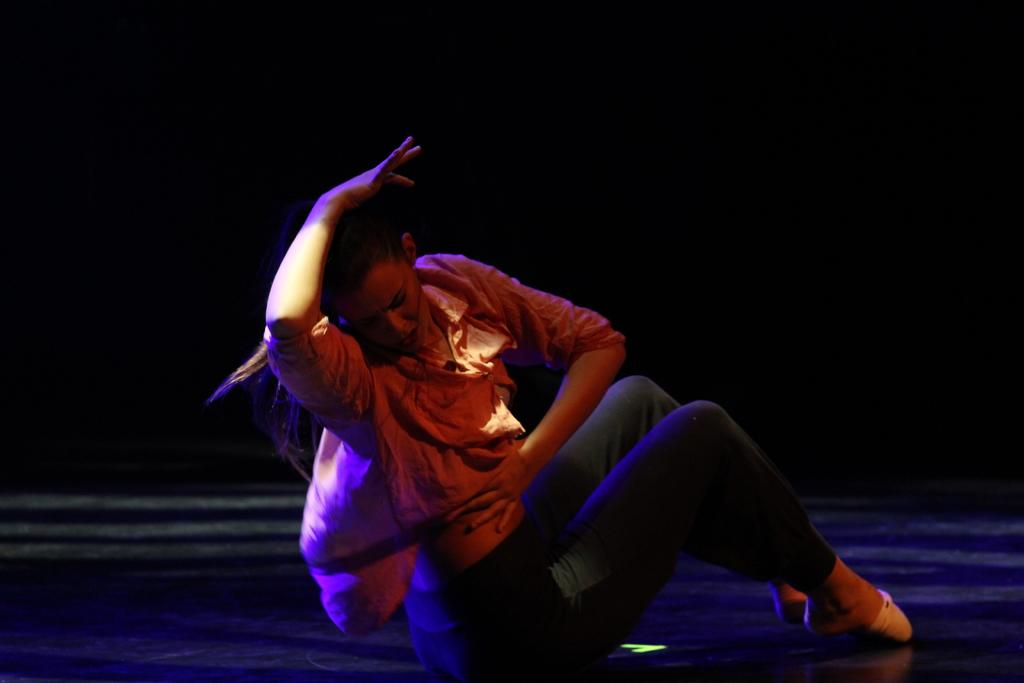Who is the main subject in the image? There is a woman in the image. What is the woman doing in the image? The woman is sitting on the floor. What type of clothing is the woman wearing? The woman is wearing a shirt and pants. How would you describe the lighting in the image? The image is in a dark setting. What type of hole can be seen in the woman's shirt in the image? There is no hole visible in the woman's shirt in the image. 